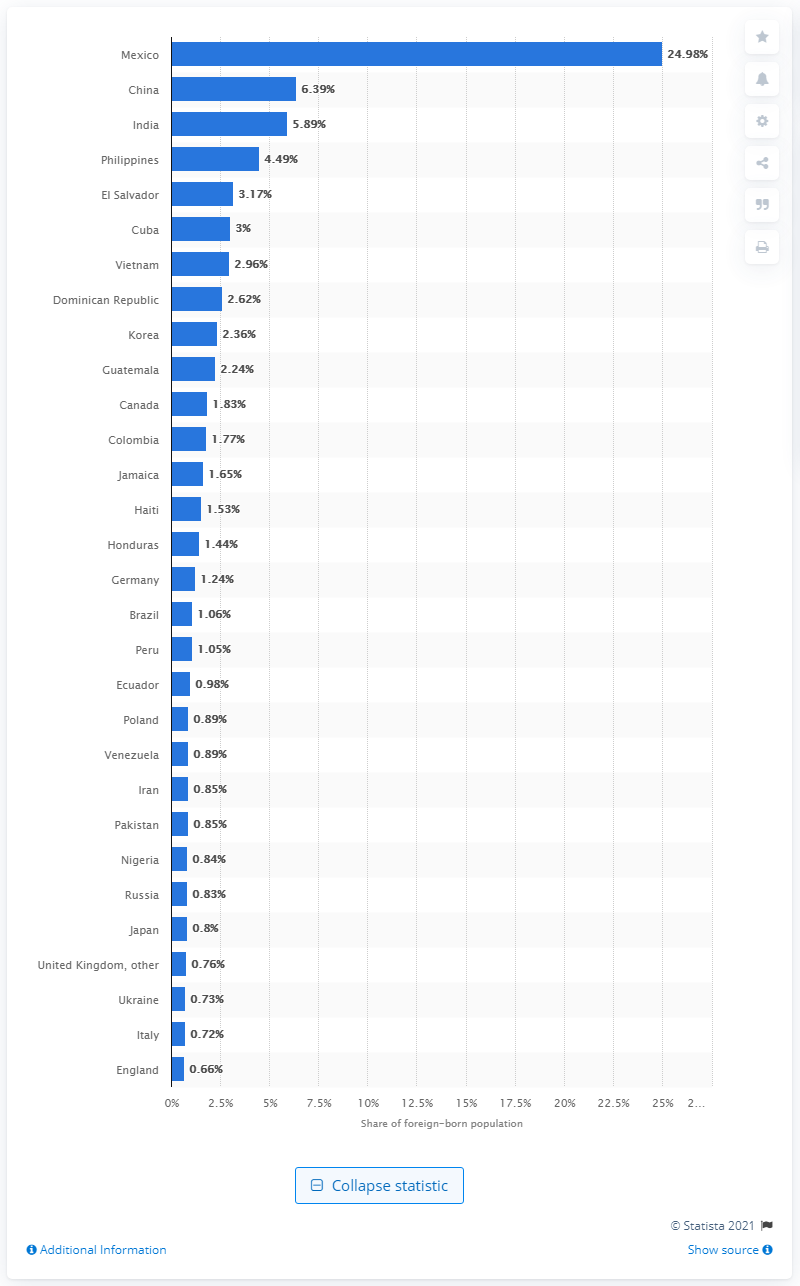Point out several critical features in this image. In 2018, 24.98% of foreign-born residents in the United States came from Mexico, according to a recent report. 